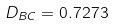Convert formula to latex. <formula><loc_0><loc_0><loc_500><loc_500>D _ { B C } = 0 . 7 2 7 3</formula> 